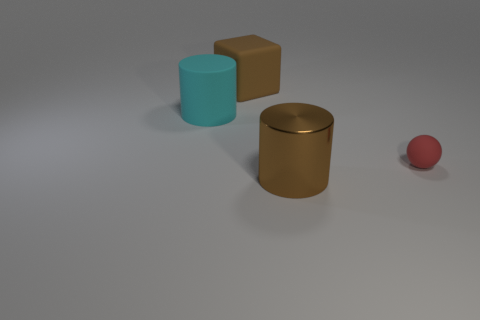Add 4 small yellow things. How many objects exist? 8 Subtract all spheres. How many objects are left? 3 Subtract all spheres. Subtract all tiny objects. How many objects are left? 2 Add 2 big brown cylinders. How many big brown cylinders are left? 3 Add 1 shiny blocks. How many shiny blocks exist? 1 Subtract 0 cyan blocks. How many objects are left? 4 